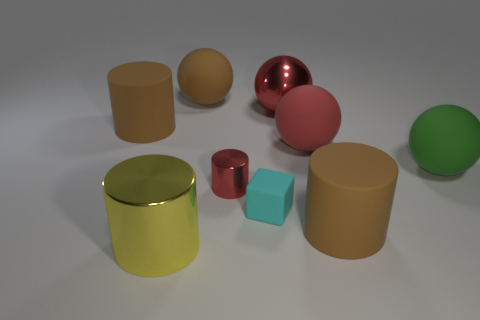How many brown cylinders must be subtracted to get 1 brown cylinders? 1 Subtract all cyan blocks. How many brown cylinders are left? 2 Subtract all large rubber balls. How many balls are left? 1 Add 1 red matte things. How many objects exist? 10 Subtract all green spheres. How many spheres are left? 3 Add 1 tiny rubber objects. How many tiny rubber objects are left? 2 Add 5 big red matte spheres. How many big red matte spheres exist? 6 Subtract 0 yellow blocks. How many objects are left? 9 Subtract all cubes. How many objects are left? 8 Subtract all purple spheres. Subtract all blue blocks. How many spheres are left? 4 